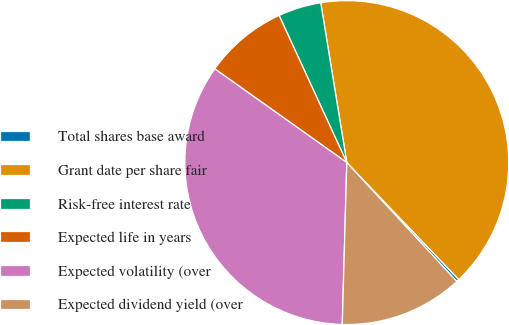<chart> <loc_0><loc_0><loc_500><loc_500><pie_chart><fcel>Total shares base award<fcel>Grant date per share fair<fcel>Risk-free interest rate<fcel>Expected life in years<fcel>Expected volatility (over<fcel>Expected dividend yield (over<nl><fcel>0.27%<fcel>40.42%<fcel>4.29%<fcel>8.31%<fcel>34.38%<fcel>12.33%<nl></chart> 